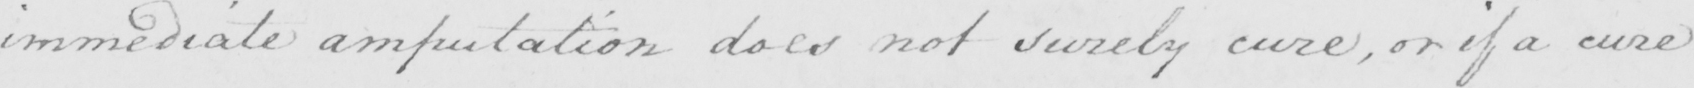What text is written in this handwritten line? immediate amputation does not surely cure , or if a cure 